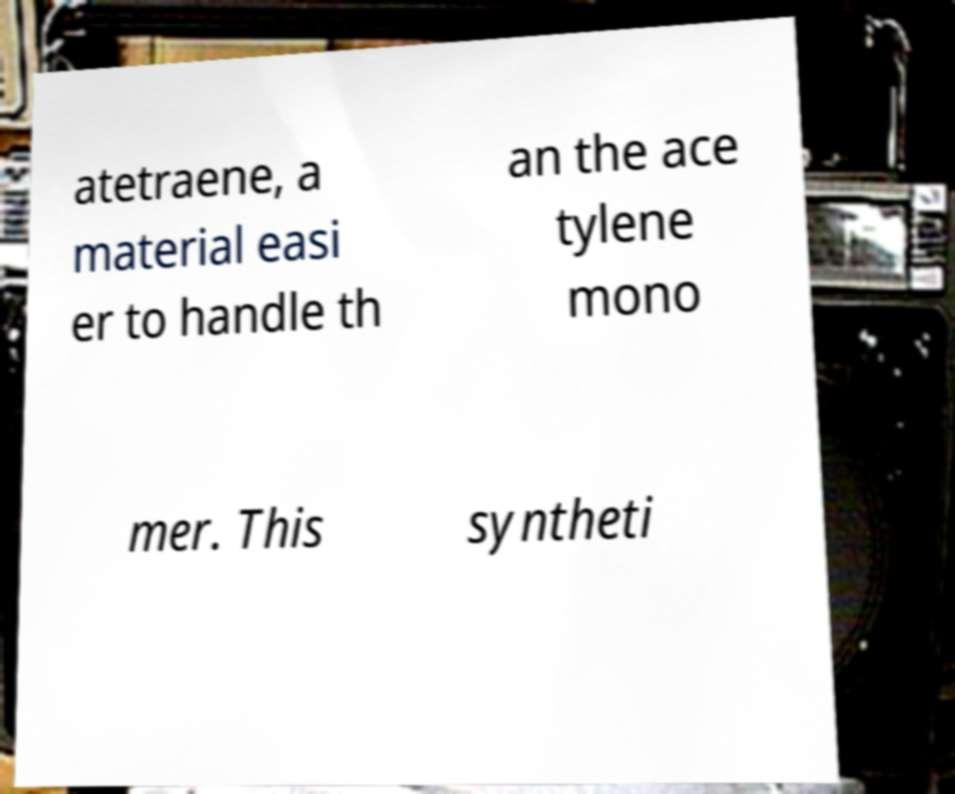For documentation purposes, I need the text within this image transcribed. Could you provide that? atetraene, a material easi er to handle th an the ace tylene mono mer. This syntheti 